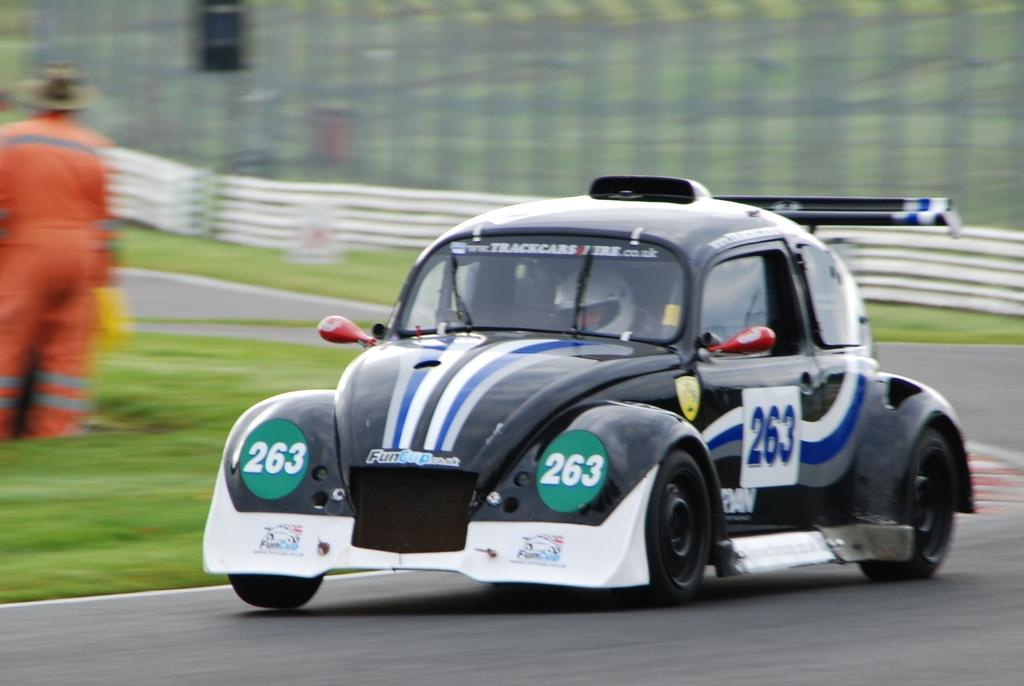What is the main subject of the image? The main subject of the image is a car. Where is the car located? The car is on a road. Are there any people in the image? Yes, there are two people in the image. What is the person standing far from the car doing? It is not clear what the person standing far from the car is doing. What is the person inside the car wearing? The person inside the car is wearing a helmet. What type of pie is being served to the person inside the car? There is no pie present in the image; the person inside the car is wearing a helmet. How does the mask help the person inside the car while driving? There is no mask present in the image; the person inside the car is wearing a helmet. 